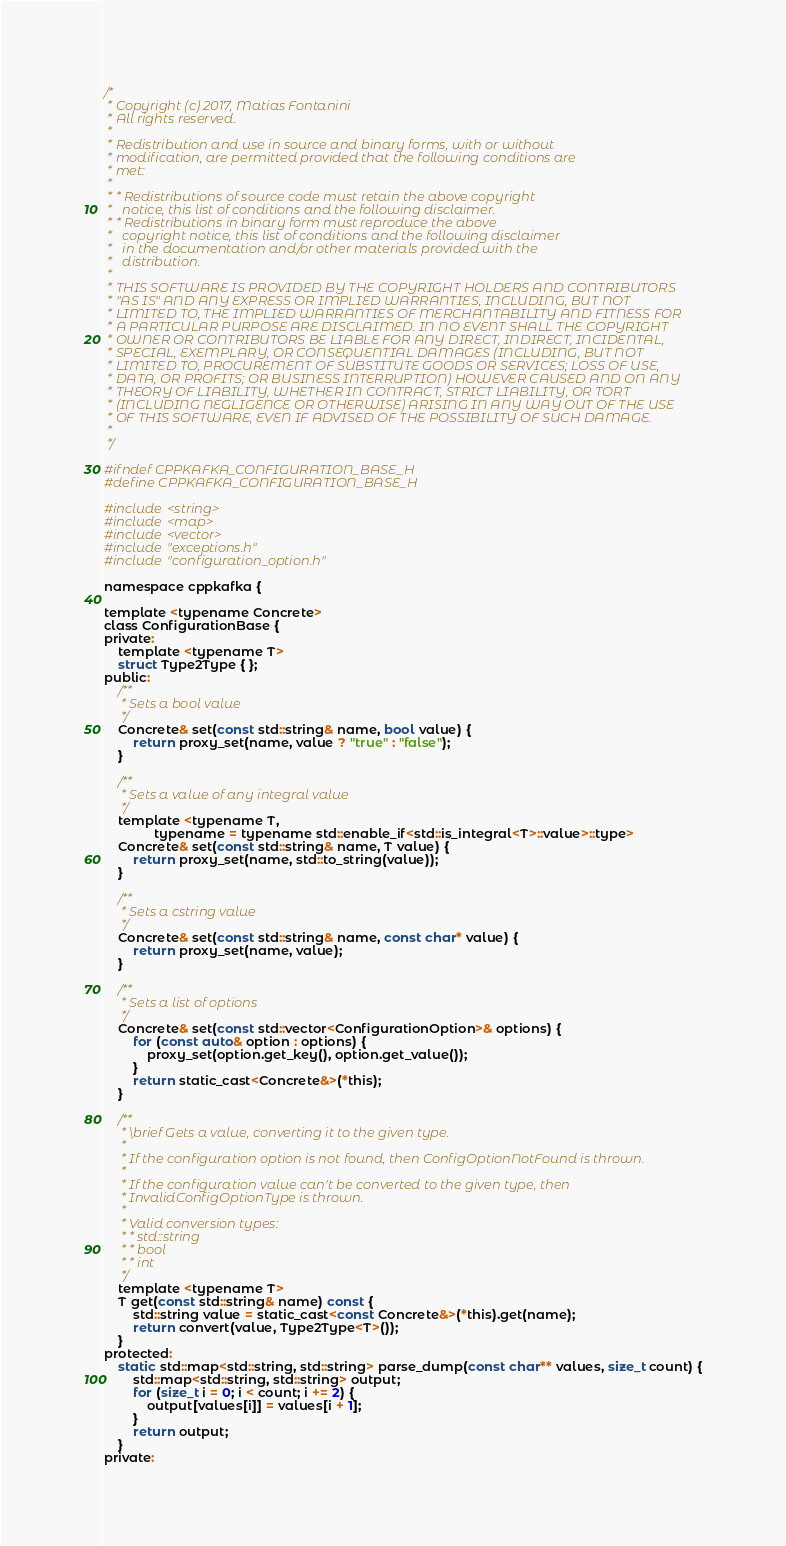<code> <loc_0><loc_0><loc_500><loc_500><_C_>/*
 * Copyright (c) 2017, Matias Fontanini
 * All rights reserved.
 *
 * Redistribution and use in source and binary forms, with or without
 * modification, are permitted provided that the following conditions are
 * met:
 *
 * * Redistributions of source code must retain the above copyright
 *   notice, this list of conditions and the following disclaimer.
 * * Redistributions in binary form must reproduce the above
 *   copyright notice, this list of conditions and the following disclaimer
 *   in the documentation and/or other materials provided with the
 *   distribution.
 *
 * THIS SOFTWARE IS PROVIDED BY THE COPYRIGHT HOLDERS AND CONTRIBUTORS
 * "AS IS" AND ANY EXPRESS OR IMPLIED WARRANTIES, INCLUDING, BUT NOT
 * LIMITED TO, THE IMPLIED WARRANTIES OF MERCHANTABILITY AND FITNESS FOR
 * A PARTICULAR PURPOSE ARE DISCLAIMED. IN NO EVENT SHALL THE COPYRIGHT
 * OWNER OR CONTRIBUTORS BE LIABLE FOR ANY DIRECT, INDIRECT, INCIDENTAL,
 * SPECIAL, EXEMPLARY, OR CONSEQUENTIAL DAMAGES (INCLUDING, BUT NOT
 * LIMITED TO, PROCUREMENT OF SUBSTITUTE GOODS OR SERVICES; LOSS OF USE,
 * DATA, OR PROFITS; OR BUSINESS INTERRUPTION) HOWEVER CAUSED AND ON ANY
 * THEORY OF LIABILITY, WHETHER IN CONTRACT, STRICT LIABILITY, OR TORT
 * (INCLUDING NEGLIGENCE OR OTHERWISE) ARISING IN ANY WAY OUT OF THE USE
 * OF THIS SOFTWARE, EVEN IF ADVISED OF THE POSSIBILITY OF SUCH DAMAGE.
 *
 */

#ifndef CPPKAFKA_CONFIGURATION_BASE_H
#define CPPKAFKA_CONFIGURATION_BASE_H

#include <string>
#include <map>
#include <vector>
#include "exceptions.h"
#include "configuration_option.h"

namespace cppkafka {

template <typename Concrete>
class ConfigurationBase {
private:
    template <typename T>
    struct Type2Type { };
public:
    /**
     * Sets a bool value
     */
    Concrete& set(const std::string& name, bool value) {
        return proxy_set(name, value ? "true" : "false");
    }

    /**
     * Sets a value of any integral value
     */
    template <typename T,
              typename = typename std::enable_if<std::is_integral<T>::value>::type>
    Concrete& set(const std::string& name, T value) {
        return proxy_set(name, std::to_string(value));
    }

    /**
     * Sets a cstring value
     */
    Concrete& set(const std::string& name, const char* value) {
        return proxy_set(name, value);
    }

    /**
     * Sets a list of options
     */
    Concrete& set(const std::vector<ConfigurationOption>& options) {
        for (const auto& option : options) {
            proxy_set(option.get_key(), option.get_value());
        }
        return static_cast<Concrete&>(*this);
    }

    /**
     * \brief Gets a value, converting it to the given type.
     *
     * If the configuration option is not found, then ConfigOptionNotFound is thrown.
     *
     * If the configuration value can't be converted to the given type, then 
     * InvalidConfigOptionType is thrown.
     *
     * Valid conversion types:
     * * std::string
     * * bool
     * * int
     */
    template <typename T>
    T get(const std::string& name) const {
        std::string value = static_cast<const Concrete&>(*this).get(name);
        return convert(value, Type2Type<T>());
    }
protected:
    static std::map<std::string, std::string> parse_dump(const char** values, size_t count) {
        std::map<std::string, std::string> output;
        for (size_t i = 0; i < count; i += 2) {
            output[values[i]] = values[i + 1];
        }
        return output;
    }
private:</code> 